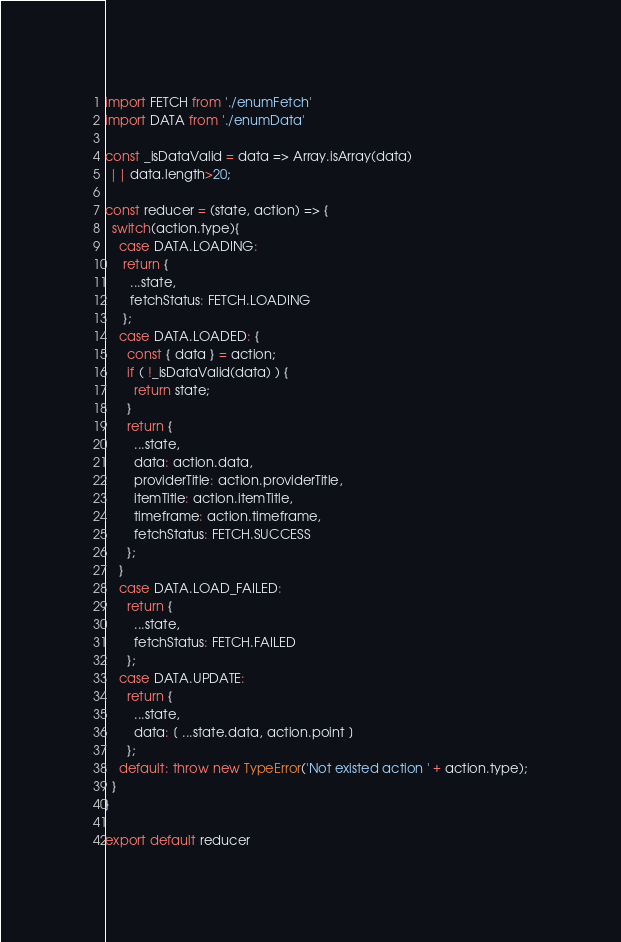<code> <loc_0><loc_0><loc_500><loc_500><_JavaScript_>import FETCH from './enumFetch'
import DATA from './enumData'

const _isDataValid = data => Array.isArray(data)
 || data.length>20;

const reducer = (state, action) => {
  switch(action.type){
    case DATA.LOADING:
     return {
       ...state,
       fetchStatus: FETCH.LOADING
     };
    case DATA.LOADED: {
      const { data } = action;
      if ( !_isDataValid(data) ) {
        return state;
      }
      return {
        ...state,
        data: action.data,
        providerTitle: action.providerTitle,
        itemTitle: action.itemTitle,
        timeframe: action.timeframe,
        fetchStatus: FETCH.SUCCESS
      };
    }
    case DATA.LOAD_FAILED:
      return {
        ...state,
        fetchStatus: FETCH.FAILED
      };
    case DATA.UPDATE:
      return {
        ...state,
        data: [ ...state.data, action.point ]
      };
    default: throw new TypeError('Not existed action ' + action.type);
  }
}

export default reducer
</code> 